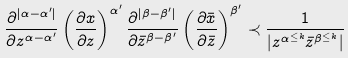<formula> <loc_0><loc_0><loc_500><loc_500>\frac { \partial ^ { | \alpha - \alpha ^ { \prime } | } } { \partial z ^ { \alpha - \alpha ^ { \prime } } } \left ( \frac { \partial x } { \partial z } \right ) ^ { \alpha ^ { \prime } } \frac { \partial ^ { | \beta - \beta ^ { \prime } | } } { \partial \bar { z } ^ { \beta - \beta ^ { \prime } } } \left ( \frac { \partial \bar { x } } { \partial \bar { z } } \right ) ^ { \beta ^ { \prime } } \prec \frac { 1 } { | z ^ { \alpha ^ { \leq k } } \bar { z } ^ { \beta ^ { \leq k } } | }</formula> 